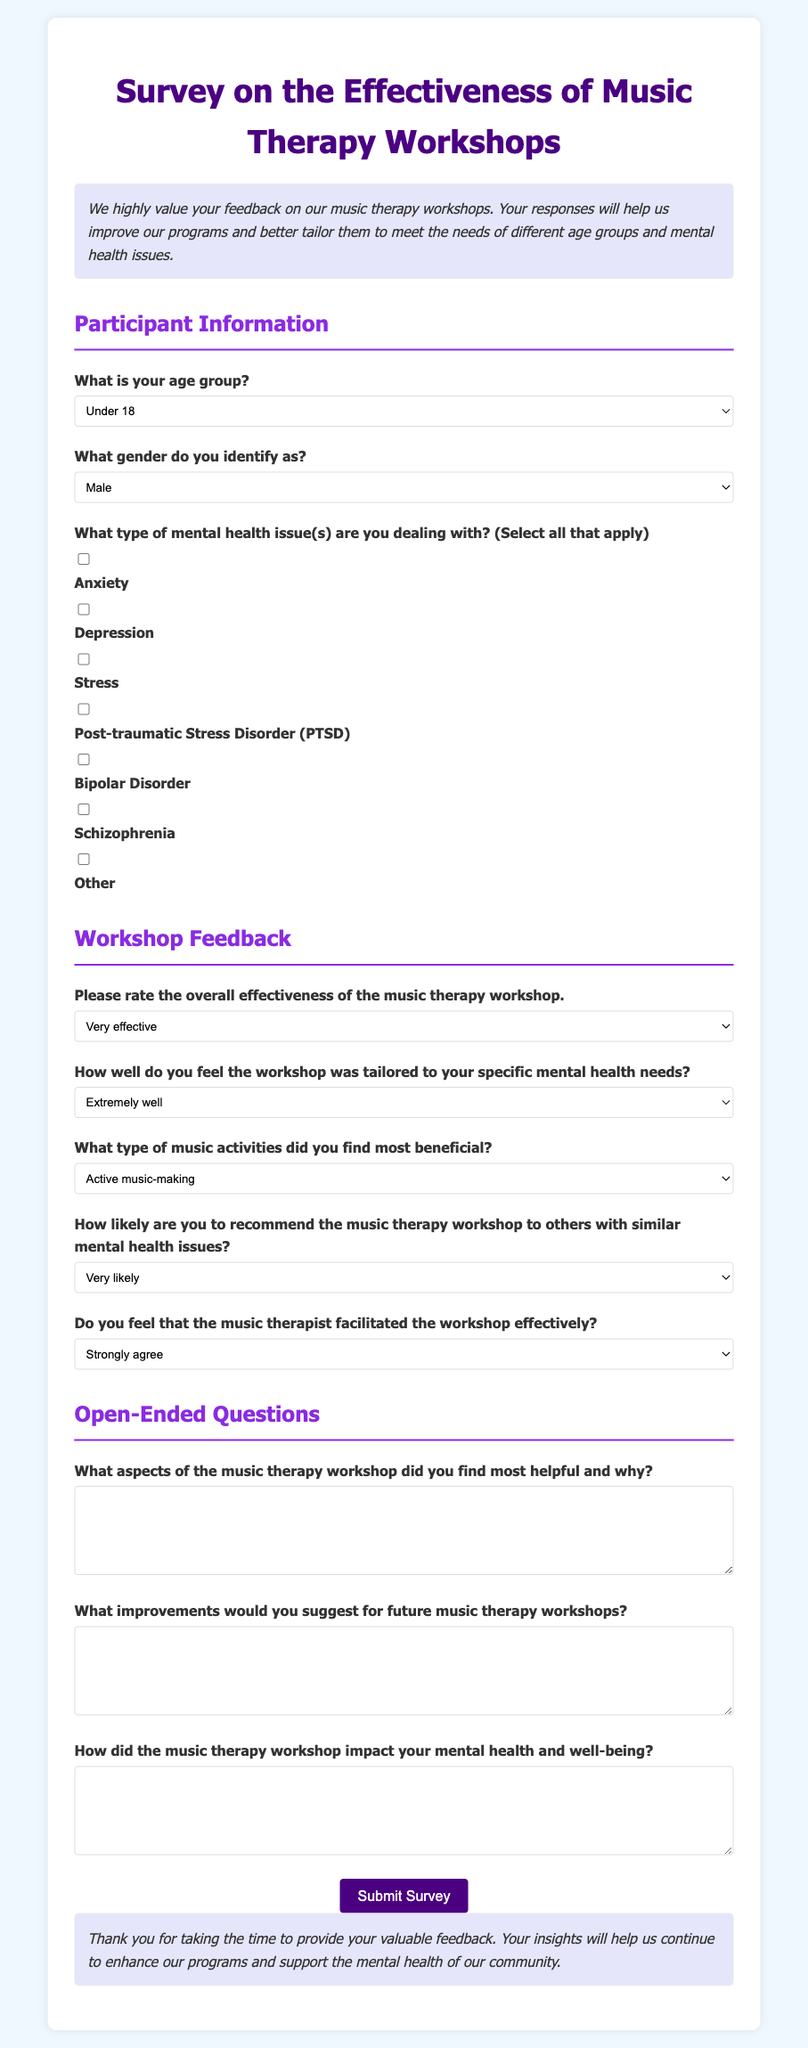What is the title of the survey? The title of the survey is stated at the top of the document, clearly indicating the focus on effectiveness and participant feedback.
Answer: Survey on the Effectiveness of Music Therapy Workshops What is one age group option in the participant information section? The document lists several age group options for participants to select from as part of their demographic information.
Answer: Under 18 How many types of mental health issues can participants select? Participants are offered multiple options to indicate their mental health issues, allowing for a comprehensive understanding of their needs.
Answer: Seven What is the question regarding the overall effectiveness of the workshop? The survey includes a question specifically asking for the participant's assessment of how effective they found the workshop to be.
Answer: Please rate the overall effectiveness of the music therapy workshop What type of feedback is requested in the open-ended questions? The survey seeks detailed feedback from participants regarding their experience and suggestions, allowing them to share personal insights.
Answer: What improvements would you suggest for future music therapy workshops? What is the purpose of the introductory section of the survey? The introduction provides context and explains the importance of participant feedback in enhancing future music therapy workshops.
Answer: To improve programs and better tailor them 